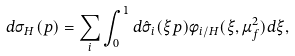Convert formula to latex. <formula><loc_0><loc_0><loc_500><loc_500>d \sigma _ { H } ( p ) = \sum _ { i } \int _ { 0 } ^ { 1 } d \hat { \sigma } _ { i } ( \xi p ) \phi _ { i / H } ( \xi , \mu ^ { 2 } _ { f } ) d \xi ,</formula> 